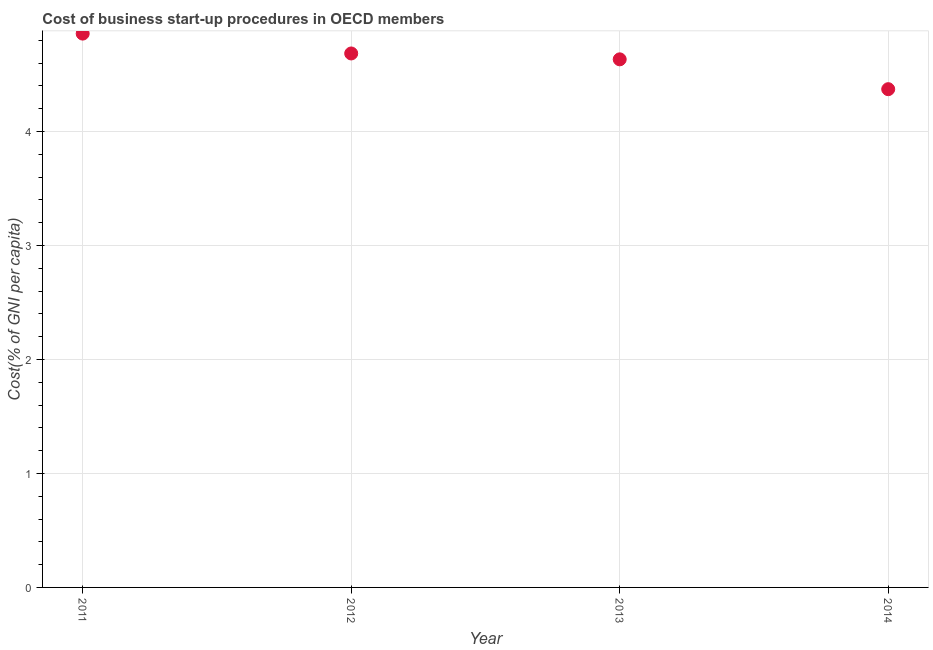What is the cost of business startup procedures in 2011?
Provide a succinct answer. 4.86. Across all years, what is the maximum cost of business startup procedures?
Provide a succinct answer. 4.86. Across all years, what is the minimum cost of business startup procedures?
Offer a very short reply. 4.37. In which year was the cost of business startup procedures maximum?
Your answer should be compact. 2011. In which year was the cost of business startup procedures minimum?
Keep it short and to the point. 2014. What is the sum of the cost of business startup procedures?
Offer a terse response. 18.54. What is the difference between the cost of business startup procedures in 2012 and 2014?
Provide a succinct answer. 0.31. What is the average cost of business startup procedures per year?
Keep it short and to the point. 4.64. What is the median cost of business startup procedures?
Offer a very short reply. 4.66. In how many years, is the cost of business startup procedures greater than 2 %?
Your answer should be compact. 4. What is the ratio of the cost of business startup procedures in 2011 to that in 2012?
Provide a succinct answer. 1.04. What is the difference between the highest and the second highest cost of business startup procedures?
Make the answer very short. 0.17. Is the sum of the cost of business startup procedures in 2011 and 2013 greater than the maximum cost of business startup procedures across all years?
Offer a very short reply. Yes. What is the difference between the highest and the lowest cost of business startup procedures?
Ensure brevity in your answer.  0.49. In how many years, is the cost of business startup procedures greater than the average cost of business startup procedures taken over all years?
Your answer should be very brief. 2. Does the cost of business startup procedures monotonically increase over the years?
Your answer should be very brief. No. How many dotlines are there?
Offer a terse response. 1. What is the difference between two consecutive major ticks on the Y-axis?
Your answer should be compact. 1. Does the graph contain any zero values?
Provide a short and direct response. No. Does the graph contain grids?
Offer a very short reply. Yes. What is the title of the graph?
Keep it short and to the point. Cost of business start-up procedures in OECD members. What is the label or title of the Y-axis?
Offer a terse response. Cost(% of GNI per capita). What is the Cost(% of GNI per capita) in 2011?
Your answer should be very brief. 4.86. What is the Cost(% of GNI per capita) in 2012?
Offer a terse response. 4.68. What is the Cost(% of GNI per capita) in 2013?
Your answer should be compact. 4.63. What is the Cost(% of GNI per capita) in 2014?
Offer a very short reply. 4.37. What is the difference between the Cost(% of GNI per capita) in 2011 and 2012?
Your answer should be very brief. 0.17. What is the difference between the Cost(% of GNI per capita) in 2011 and 2013?
Provide a succinct answer. 0.23. What is the difference between the Cost(% of GNI per capita) in 2011 and 2014?
Keep it short and to the point. 0.49. What is the difference between the Cost(% of GNI per capita) in 2012 and 2013?
Your answer should be compact. 0.05. What is the difference between the Cost(% of GNI per capita) in 2012 and 2014?
Give a very brief answer. 0.31. What is the difference between the Cost(% of GNI per capita) in 2013 and 2014?
Your answer should be compact. 0.26. What is the ratio of the Cost(% of GNI per capita) in 2011 to that in 2012?
Your response must be concise. 1.04. What is the ratio of the Cost(% of GNI per capita) in 2011 to that in 2013?
Your answer should be compact. 1.05. What is the ratio of the Cost(% of GNI per capita) in 2011 to that in 2014?
Your answer should be very brief. 1.11. What is the ratio of the Cost(% of GNI per capita) in 2012 to that in 2014?
Provide a short and direct response. 1.07. What is the ratio of the Cost(% of GNI per capita) in 2013 to that in 2014?
Ensure brevity in your answer.  1.06. 